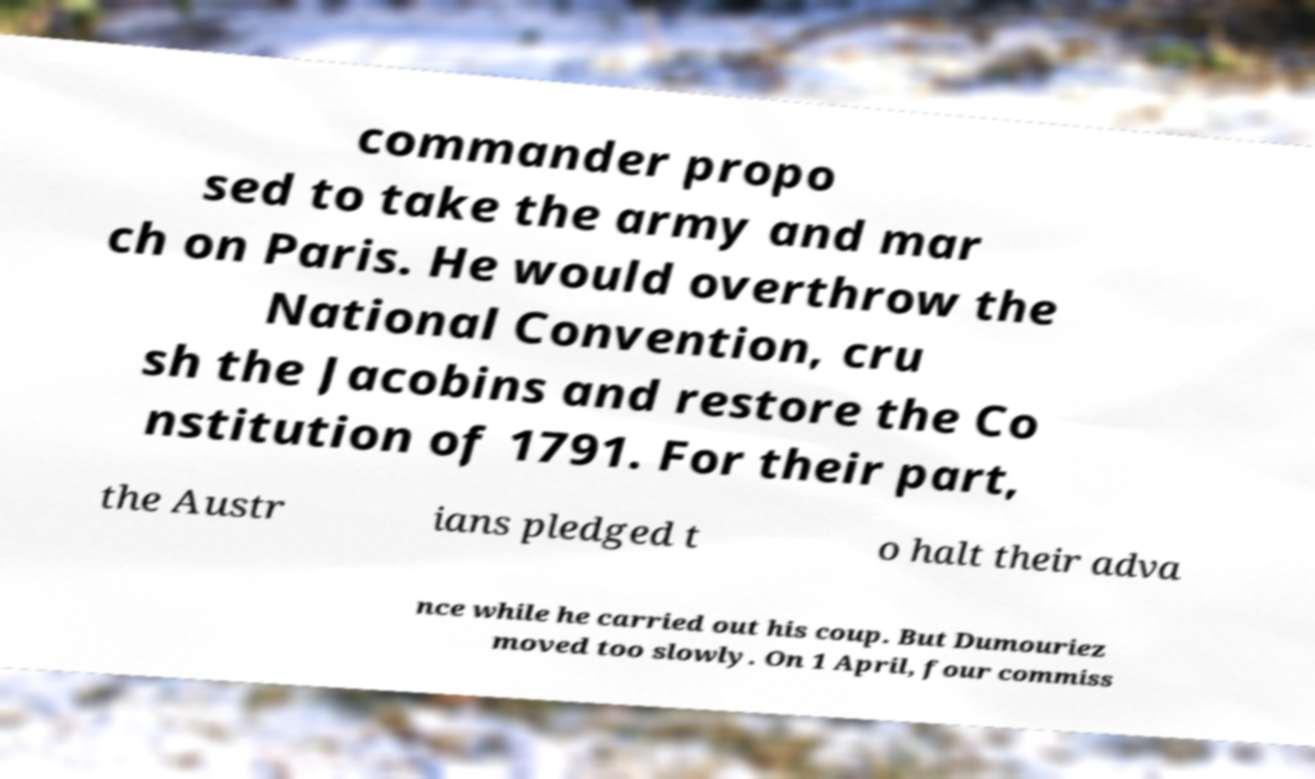Please read and relay the text visible in this image. What does it say? commander propo sed to take the army and mar ch on Paris. He would overthrow the National Convention, cru sh the Jacobins and restore the Co nstitution of 1791. For their part, the Austr ians pledged t o halt their adva nce while he carried out his coup. But Dumouriez moved too slowly. On 1 April, four commiss 